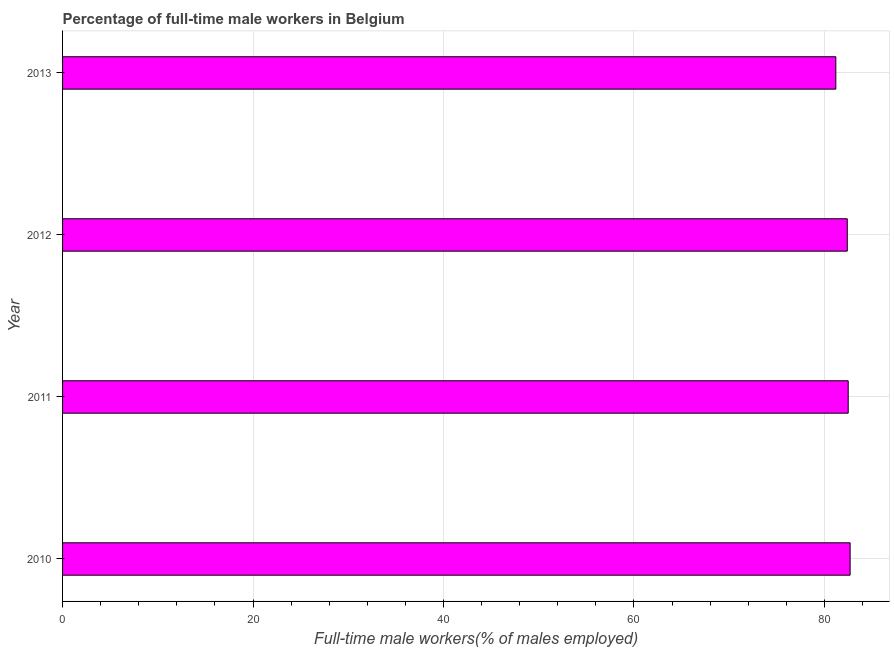Does the graph contain any zero values?
Keep it short and to the point. No. What is the title of the graph?
Your answer should be very brief. Percentage of full-time male workers in Belgium. What is the label or title of the X-axis?
Provide a succinct answer. Full-time male workers(% of males employed). What is the percentage of full-time male workers in 2013?
Your response must be concise. 81.2. Across all years, what is the maximum percentage of full-time male workers?
Provide a short and direct response. 82.7. Across all years, what is the minimum percentage of full-time male workers?
Offer a very short reply. 81.2. What is the sum of the percentage of full-time male workers?
Offer a terse response. 328.8. What is the average percentage of full-time male workers per year?
Provide a succinct answer. 82.2. What is the median percentage of full-time male workers?
Your response must be concise. 82.45. Do a majority of the years between 2011 and 2012 (inclusive) have percentage of full-time male workers greater than 52 %?
Provide a succinct answer. Yes. What is the difference between the highest and the lowest percentage of full-time male workers?
Provide a succinct answer. 1.5. How many bars are there?
Ensure brevity in your answer.  4. How many years are there in the graph?
Make the answer very short. 4. What is the difference between two consecutive major ticks on the X-axis?
Offer a terse response. 20. What is the Full-time male workers(% of males employed) in 2010?
Your answer should be compact. 82.7. What is the Full-time male workers(% of males employed) of 2011?
Offer a very short reply. 82.5. What is the Full-time male workers(% of males employed) in 2012?
Your answer should be compact. 82.4. What is the Full-time male workers(% of males employed) in 2013?
Your response must be concise. 81.2. What is the difference between the Full-time male workers(% of males employed) in 2010 and 2013?
Keep it short and to the point. 1.5. What is the difference between the Full-time male workers(% of males employed) in 2011 and 2013?
Your answer should be very brief. 1.3. What is the ratio of the Full-time male workers(% of males employed) in 2010 to that in 2011?
Your answer should be very brief. 1. What is the ratio of the Full-time male workers(% of males employed) in 2011 to that in 2012?
Your answer should be very brief. 1. What is the ratio of the Full-time male workers(% of males employed) in 2011 to that in 2013?
Your answer should be compact. 1.02. What is the ratio of the Full-time male workers(% of males employed) in 2012 to that in 2013?
Offer a very short reply. 1.01. 